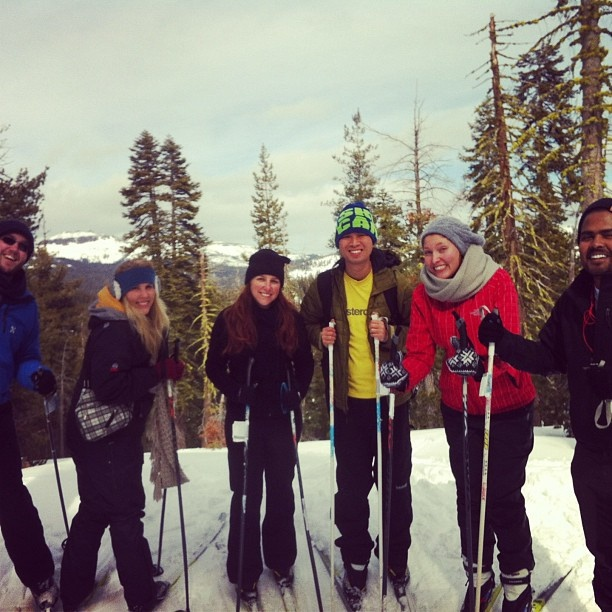Describe the objects in this image and their specific colors. I can see people in lightgray, black, brown, maroon, and darkgray tones, people in lightgray, black, maroon, brown, and darkgray tones, people in lightgray, black, gray, maroon, and brown tones, people in lightgray, black, maroon, gray, and brown tones, and people in lightgray, black, maroon, brown, and gray tones in this image. 